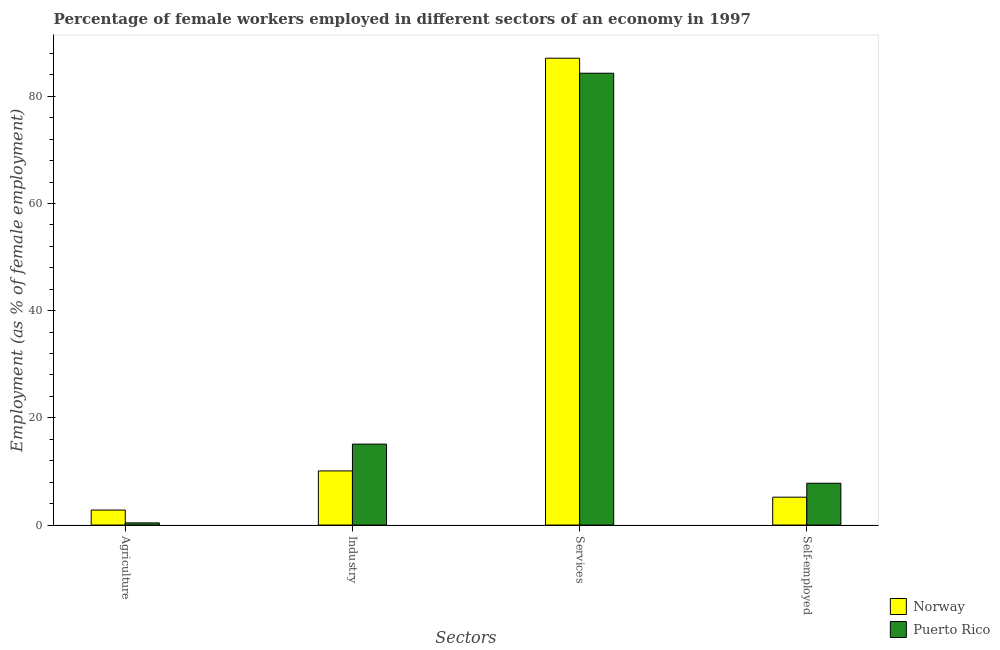How many groups of bars are there?
Make the answer very short. 4. Are the number of bars on each tick of the X-axis equal?
Keep it short and to the point. Yes. How many bars are there on the 2nd tick from the left?
Keep it short and to the point. 2. How many bars are there on the 4th tick from the right?
Offer a terse response. 2. What is the label of the 3rd group of bars from the left?
Give a very brief answer. Services. What is the percentage of self employed female workers in Norway?
Provide a succinct answer. 5.2. Across all countries, what is the maximum percentage of female workers in industry?
Give a very brief answer. 15.1. Across all countries, what is the minimum percentage of self employed female workers?
Offer a terse response. 5.2. In which country was the percentage of self employed female workers maximum?
Your response must be concise. Puerto Rico. In which country was the percentage of female workers in services minimum?
Your response must be concise. Puerto Rico. What is the total percentage of self employed female workers in the graph?
Offer a very short reply. 13. What is the difference between the percentage of female workers in agriculture in Puerto Rico and that in Norway?
Provide a short and direct response. -2.4. What is the difference between the percentage of female workers in services in Puerto Rico and the percentage of female workers in industry in Norway?
Provide a succinct answer. 74.2. What is the average percentage of female workers in agriculture per country?
Give a very brief answer. 1.6. What is the difference between the percentage of female workers in agriculture and percentage of female workers in services in Norway?
Your answer should be compact. -84.3. What is the ratio of the percentage of self employed female workers in Norway to that in Puerto Rico?
Provide a short and direct response. 0.67. Is the percentage of female workers in services in Norway less than that in Puerto Rico?
Keep it short and to the point. No. Is the difference between the percentage of female workers in services in Norway and Puerto Rico greater than the difference between the percentage of female workers in agriculture in Norway and Puerto Rico?
Your answer should be very brief. Yes. What is the difference between the highest and the second highest percentage of female workers in services?
Offer a terse response. 2.8. What is the difference between the highest and the lowest percentage of self employed female workers?
Ensure brevity in your answer.  2.6. In how many countries, is the percentage of female workers in industry greater than the average percentage of female workers in industry taken over all countries?
Provide a succinct answer. 1. Is it the case that in every country, the sum of the percentage of female workers in agriculture and percentage of female workers in industry is greater than the sum of percentage of self employed female workers and percentage of female workers in services?
Give a very brief answer. Yes. What does the 2nd bar from the right in Agriculture represents?
Your answer should be very brief. Norway. What is the difference between two consecutive major ticks on the Y-axis?
Provide a succinct answer. 20. Does the graph contain any zero values?
Offer a very short reply. No. What is the title of the graph?
Offer a very short reply. Percentage of female workers employed in different sectors of an economy in 1997. Does "Algeria" appear as one of the legend labels in the graph?
Offer a very short reply. No. What is the label or title of the X-axis?
Offer a very short reply. Sectors. What is the label or title of the Y-axis?
Offer a terse response. Employment (as % of female employment). What is the Employment (as % of female employment) of Norway in Agriculture?
Provide a short and direct response. 2.8. What is the Employment (as % of female employment) of Puerto Rico in Agriculture?
Your response must be concise. 0.4. What is the Employment (as % of female employment) of Norway in Industry?
Your response must be concise. 10.1. What is the Employment (as % of female employment) in Puerto Rico in Industry?
Give a very brief answer. 15.1. What is the Employment (as % of female employment) of Norway in Services?
Give a very brief answer. 87.1. What is the Employment (as % of female employment) of Puerto Rico in Services?
Offer a very short reply. 84.3. What is the Employment (as % of female employment) of Norway in Self-employed?
Make the answer very short. 5.2. What is the Employment (as % of female employment) in Puerto Rico in Self-employed?
Offer a very short reply. 7.8. Across all Sectors, what is the maximum Employment (as % of female employment) in Norway?
Offer a terse response. 87.1. Across all Sectors, what is the maximum Employment (as % of female employment) in Puerto Rico?
Give a very brief answer. 84.3. Across all Sectors, what is the minimum Employment (as % of female employment) in Norway?
Offer a terse response. 2.8. Across all Sectors, what is the minimum Employment (as % of female employment) in Puerto Rico?
Offer a terse response. 0.4. What is the total Employment (as % of female employment) of Norway in the graph?
Ensure brevity in your answer.  105.2. What is the total Employment (as % of female employment) in Puerto Rico in the graph?
Your answer should be compact. 107.6. What is the difference between the Employment (as % of female employment) of Puerto Rico in Agriculture and that in Industry?
Offer a very short reply. -14.7. What is the difference between the Employment (as % of female employment) in Norway in Agriculture and that in Services?
Provide a succinct answer. -84.3. What is the difference between the Employment (as % of female employment) of Puerto Rico in Agriculture and that in Services?
Offer a very short reply. -83.9. What is the difference between the Employment (as % of female employment) in Puerto Rico in Agriculture and that in Self-employed?
Make the answer very short. -7.4. What is the difference between the Employment (as % of female employment) of Norway in Industry and that in Services?
Offer a terse response. -77. What is the difference between the Employment (as % of female employment) of Puerto Rico in Industry and that in Services?
Ensure brevity in your answer.  -69.2. What is the difference between the Employment (as % of female employment) of Norway in Industry and that in Self-employed?
Keep it short and to the point. 4.9. What is the difference between the Employment (as % of female employment) in Norway in Services and that in Self-employed?
Provide a short and direct response. 81.9. What is the difference between the Employment (as % of female employment) in Puerto Rico in Services and that in Self-employed?
Keep it short and to the point. 76.5. What is the difference between the Employment (as % of female employment) in Norway in Agriculture and the Employment (as % of female employment) in Puerto Rico in Services?
Your answer should be compact. -81.5. What is the difference between the Employment (as % of female employment) in Norway in Agriculture and the Employment (as % of female employment) in Puerto Rico in Self-employed?
Your answer should be very brief. -5. What is the difference between the Employment (as % of female employment) of Norway in Industry and the Employment (as % of female employment) of Puerto Rico in Services?
Your answer should be compact. -74.2. What is the difference between the Employment (as % of female employment) of Norway in Services and the Employment (as % of female employment) of Puerto Rico in Self-employed?
Offer a terse response. 79.3. What is the average Employment (as % of female employment) in Norway per Sectors?
Ensure brevity in your answer.  26.3. What is the average Employment (as % of female employment) of Puerto Rico per Sectors?
Your answer should be very brief. 26.9. What is the difference between the Employment (as % of female employment) of Norway and Employment (as % of female employment) of Puerto Rico in Agriculture?
Your response must be concise. 2.4. What is the difference between the Employment (as % of female employment) in Norway and Employment (as % of female employment) in Puerto Rico in Industry?
Provide a succinct answer. -5. What is the difference between the Employment (as % of female employment) in Norway and Employment (as % of female employment) in Puerto Rico in Services?
Your answer should be very brief. 2.8. What is the ratio of the Employment (as % of female employment) in Norway in Agriculture to that in Industry?
Your response must be concise. 0.28. What is the ratio of the Employment (as % of female employment) in Puerto Rico in Agriculture to that in Industry?
Ensure brevity in your answer.  0.03. What is the ratio of the Employment (as % of female employment) in Norway in Agriculture to that in Services?
Your response must be concise. 0.03. What is the ratio of the Employment (as % of female employment) in Puerto Rico in Agriculture to that in Services?
Keep it short and to the point. 0. What is the ratio of the Employment (as % of female employment) in Norway in Agriculture to that in Self-employed?
Your answer should be compact. 0.54. What is the ratio of the Employment (as % of female employment) of Puerto Rico in Agriculture to that in Self-employed?
Your answer should be very brief. 0.05. What is the ratio of the Employment (as % of female employment) in Norway in Industry to that in Services?
Your answer should be compact. 0.12. What is the ratio of the Employment (as % of female employment) of Puerto Rico in Industry to that in Services?
Keep it short and to the point. 0.18. What is the ratio of the Employment (as % of female employment) in Norway in Industry to that in Self-employed?
Give a very brief answer. 1.94. What is the ratio of the Employment (as % of female employment) in Puerto Rico in Industry to that in Self-employed?
Provide a succinct answer. 1.94. What is the ratio of the Employment (as % of female employment) of Norway in Services to that in Self-employed?
Keep it short and to the point. 16.75. What is the ratio of the Employment (as % of female employment) of Puerto Rico in Services to that in Self-employed?
Provide a succinct answer. 10.81. What is the difference between the highest and the second highest Employment (as % of female employment) of Norway?
Provide a short and direct response. 77. What is the difference between the highest and the second highest Employment (as % of female employment) of Puerto Rico?
Offer a very short reply. 69.2. What is the difference between the highest and the lowest Employment (as % of female employment) in Norway?
Your response must be concise. 84.3. What is the difference between the highest and the lowest Employment (as % of female employment) of Puerto Rico?
Offer a terse response. 83.9. 